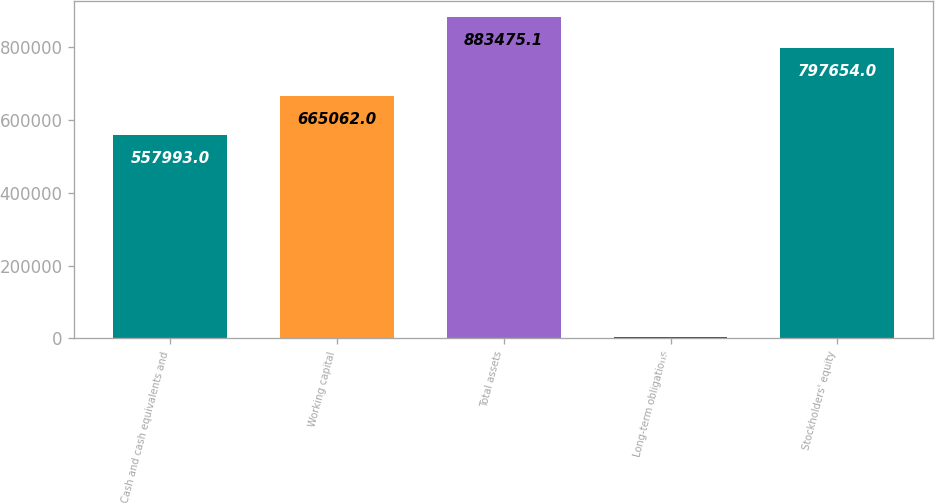Convert chart. <chart><loc_0><loc_0><loc_500><loc_500><bar_chart><fcel>Cash and cash equivalents and<fcel>Working capital<fcel>Total assets<fcel>Long-term obligations<fcel>Stockholders' equity<nl><fcel>557993<fcel>665062<fcel>883475<fcel>4011<fcel>797654<nl></chart> 